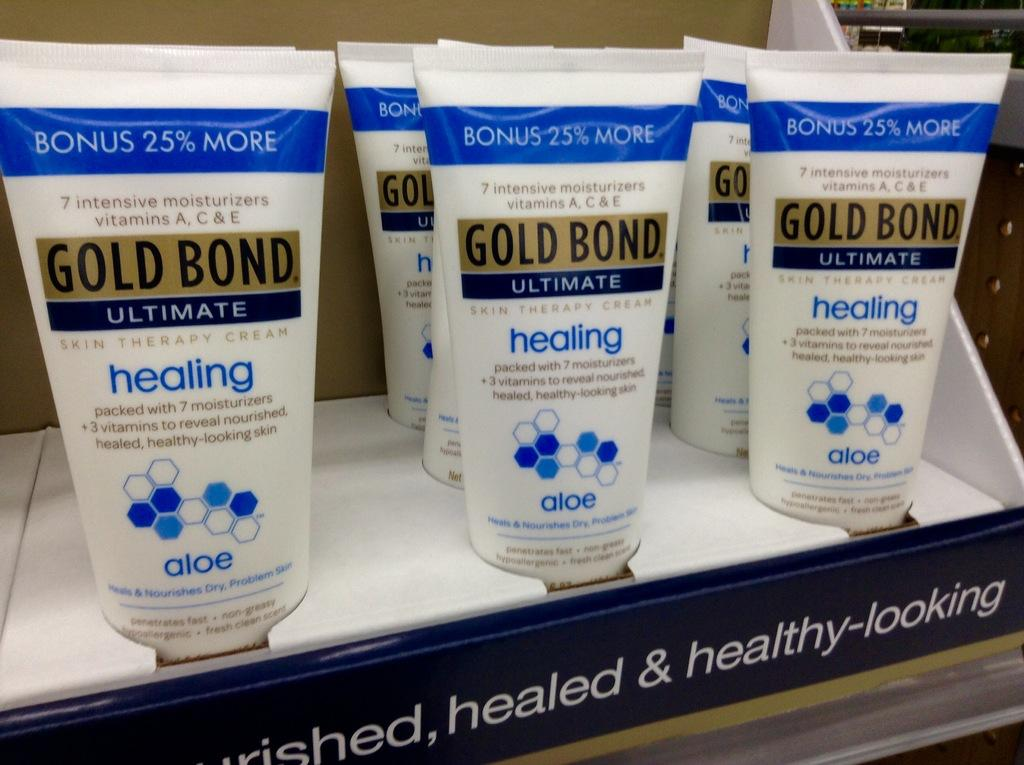<image>
Summarize the visual content of the image. The product in the box is called Gold Bond 